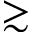<formula> <loc_0><loc_0><loc_500><loc_500>\gtrsim</formula> 